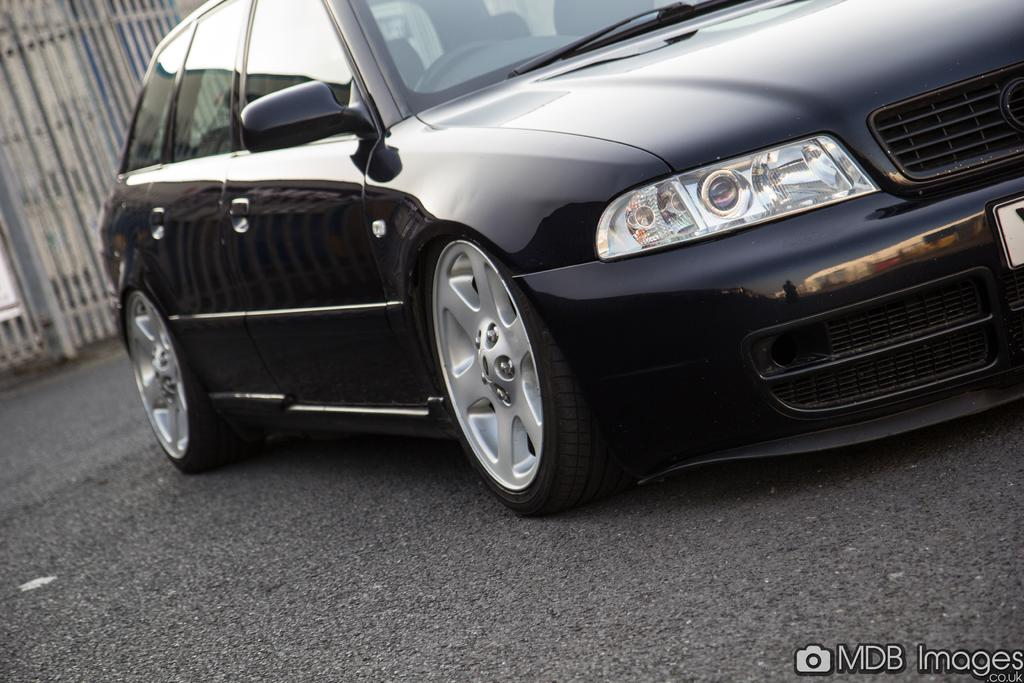What color is the car in the image? The car in the image is black. Where is the car located in the image? The car is on the road. What can be seen in the background of the image? There is a fence in the background of the image. What type of crack can be seen in the car's windshield in the image? There is no crack visible in the car's windshield in the image. What acoustics can be heard coming from the car in the image? There is no sound or acoustics mentioned or visible in the image. 